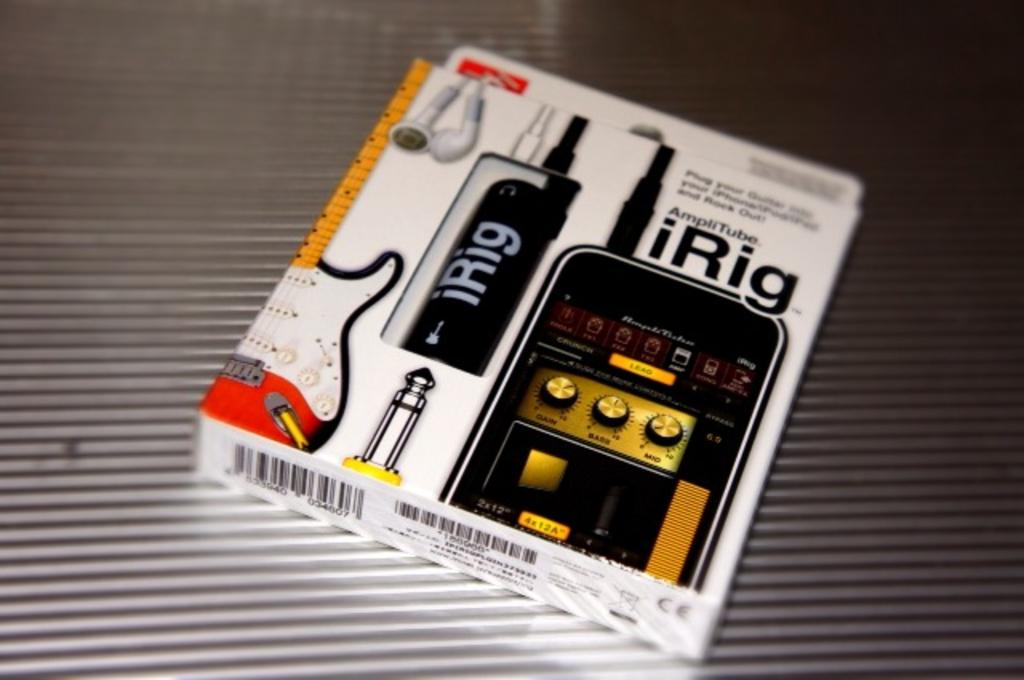<image>
Share a concise interpretation of the image provided. IRig is a device that can convert an iPhone into a guitar accessory. 